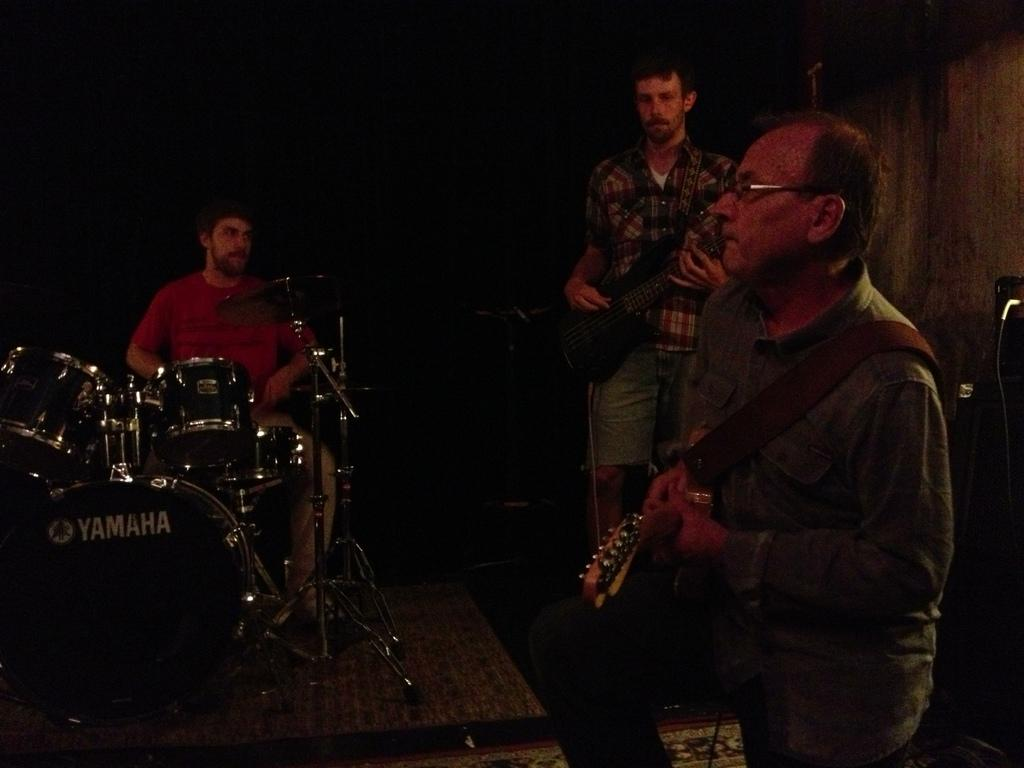How many men are in the image? There are men in the image. What are two of the men doing in the image? Two of the men are holding musical instruments. Can you describe the position of the man sitting next to a drum set? There is a man sitting next to a drum set in the image. What type of bead is being used to adjust the sound of the guitar in the image? There is no bead present in the image, and no adjustments to the sound of the guitar are depicted. 